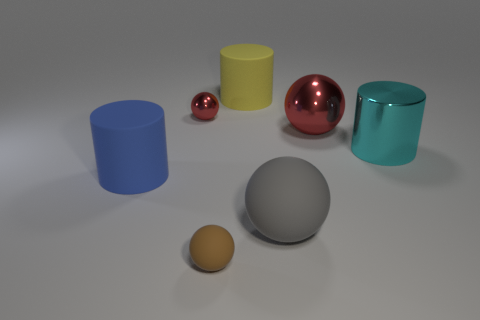Are there more small blue metallic cubes than tiny brown rubber objects?
Give a very brief answer. No. What is the size of the rubber object that is both to the right of the brown rubber object and in front of the big yellow object?
Provide a succinct answer. Large. There is a cyan shiny object; what shape is it?
Provide a short and direct response. Cylinder. Are there any other things that have the same size as the blue cylinder?
Give a very brief answer. Yes. Are there more metal spheres to the right of the yellow matte cylinder than matte balls?
Give a very brief answer. No. The rubber thing behind the large matte cylinder that is in front of the big metallic object that is behind the big cyan metallic cylinder is what shape?
Give a very brief answer. Cylinder. Is the size of the matte object behind the blue object the same as the big cyan shiny cylinder?
Your response must be concise. Yes. What shape is the matte object that is behind the gray matte sphere and on the left side of the yellow matte object?
Your response must be concise. Cylinder. There is a tiny rubber ball; is it the same color as the big sphere that is right of the big matte sphere?
Make the answer very short. No. The large cylinder that is behind the red thing on the left side of the big shiny object that is left of the metal cylinder is what color?
Offer a terse response. Yellow. 